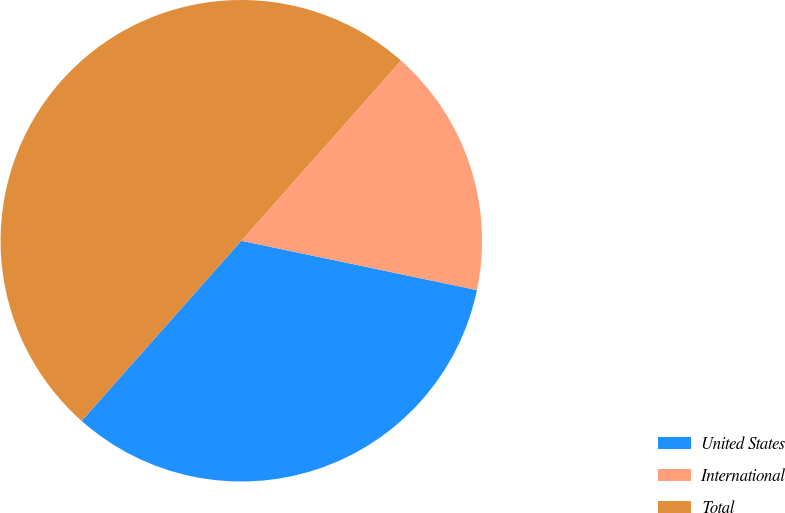Convert chart. <chart><loc_0><loc_0><loc_500><loc_500><pie_chart><fcel>United States<fcel>International<fcel>Total<nl><fcel>33.26%<fcel>16.74%<fcel>50.0%<nl></chart> 